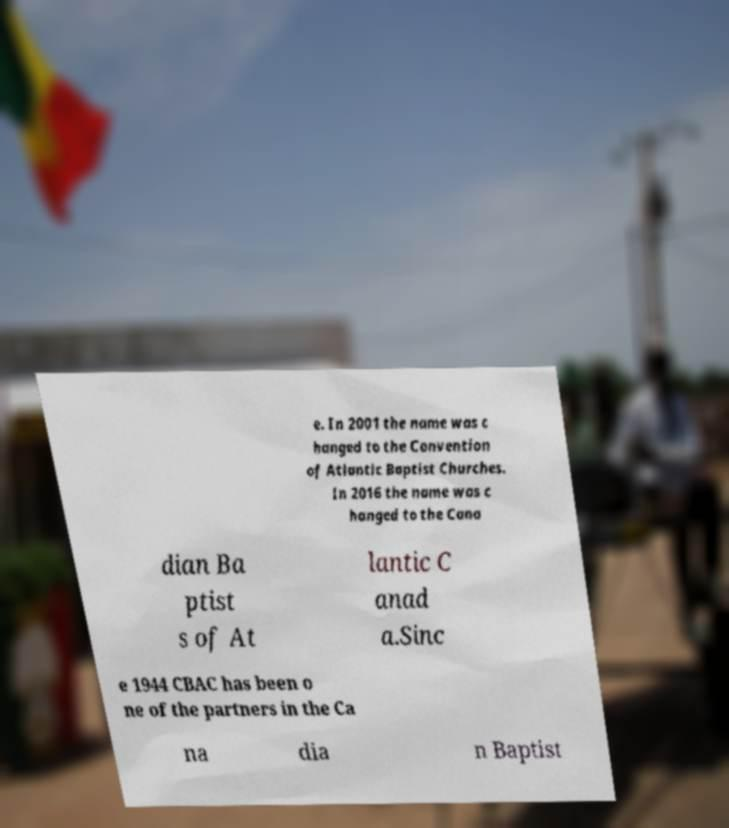Can you read and provide the text displayed in the image?This photo seems to have some interesting text. Can you extract and type it out for me? e. In 2001 the name was c hanged to the Convention of Atlantic Baptist Churches. In 2016 the name was c hanged to the Cana dian Ba ptist s of At lantic C anad a.Sinc e 1944 CBAC has been o ne of the partners in the Ca na dia n Baptist 